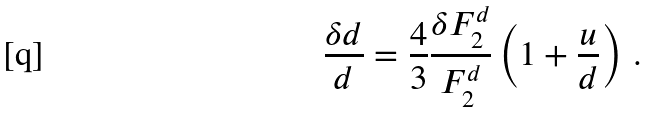<formula> <loc_0><loc_0><loc_500><loc_500>\frac { \delta d } { d } = \frac { 4 } { 3 } \frac { \delta F _ { 2 } ^ { d } } { F _ { 2 } ^ { d } } \left ( 1 + \frac { u } { d } \right ) \, .</formula> 